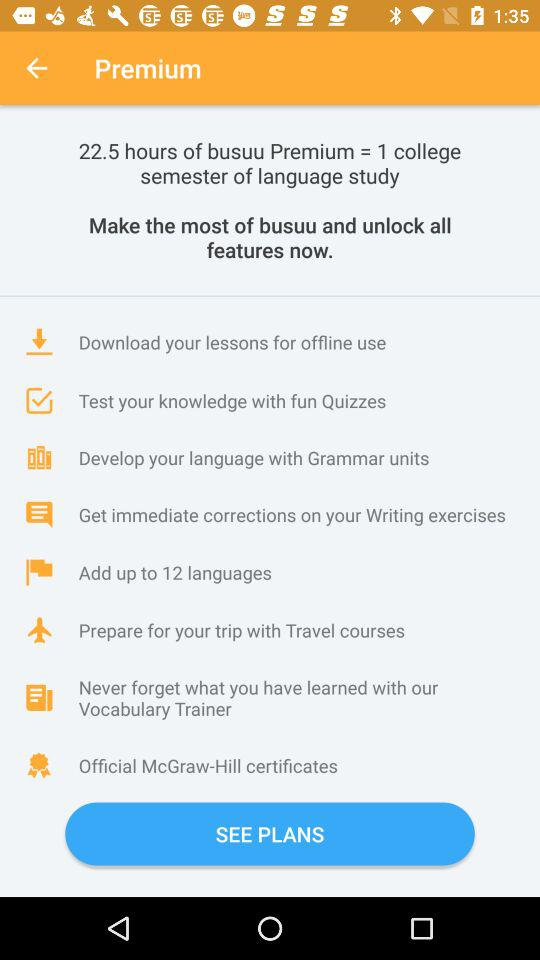What is the name of the application? The name of the application is "Premium". 